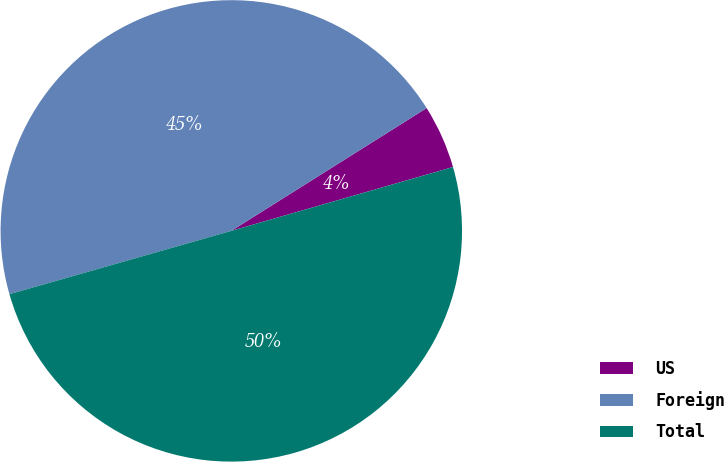<chart> <loc_0><loc_0><loc_500><loc_500><pie_chart><fcel>US<fcel>Foreign<fcel>Total<nl><fcel>4.47%<fcel>45.49%<fcel>50.04%<nl></chart> 